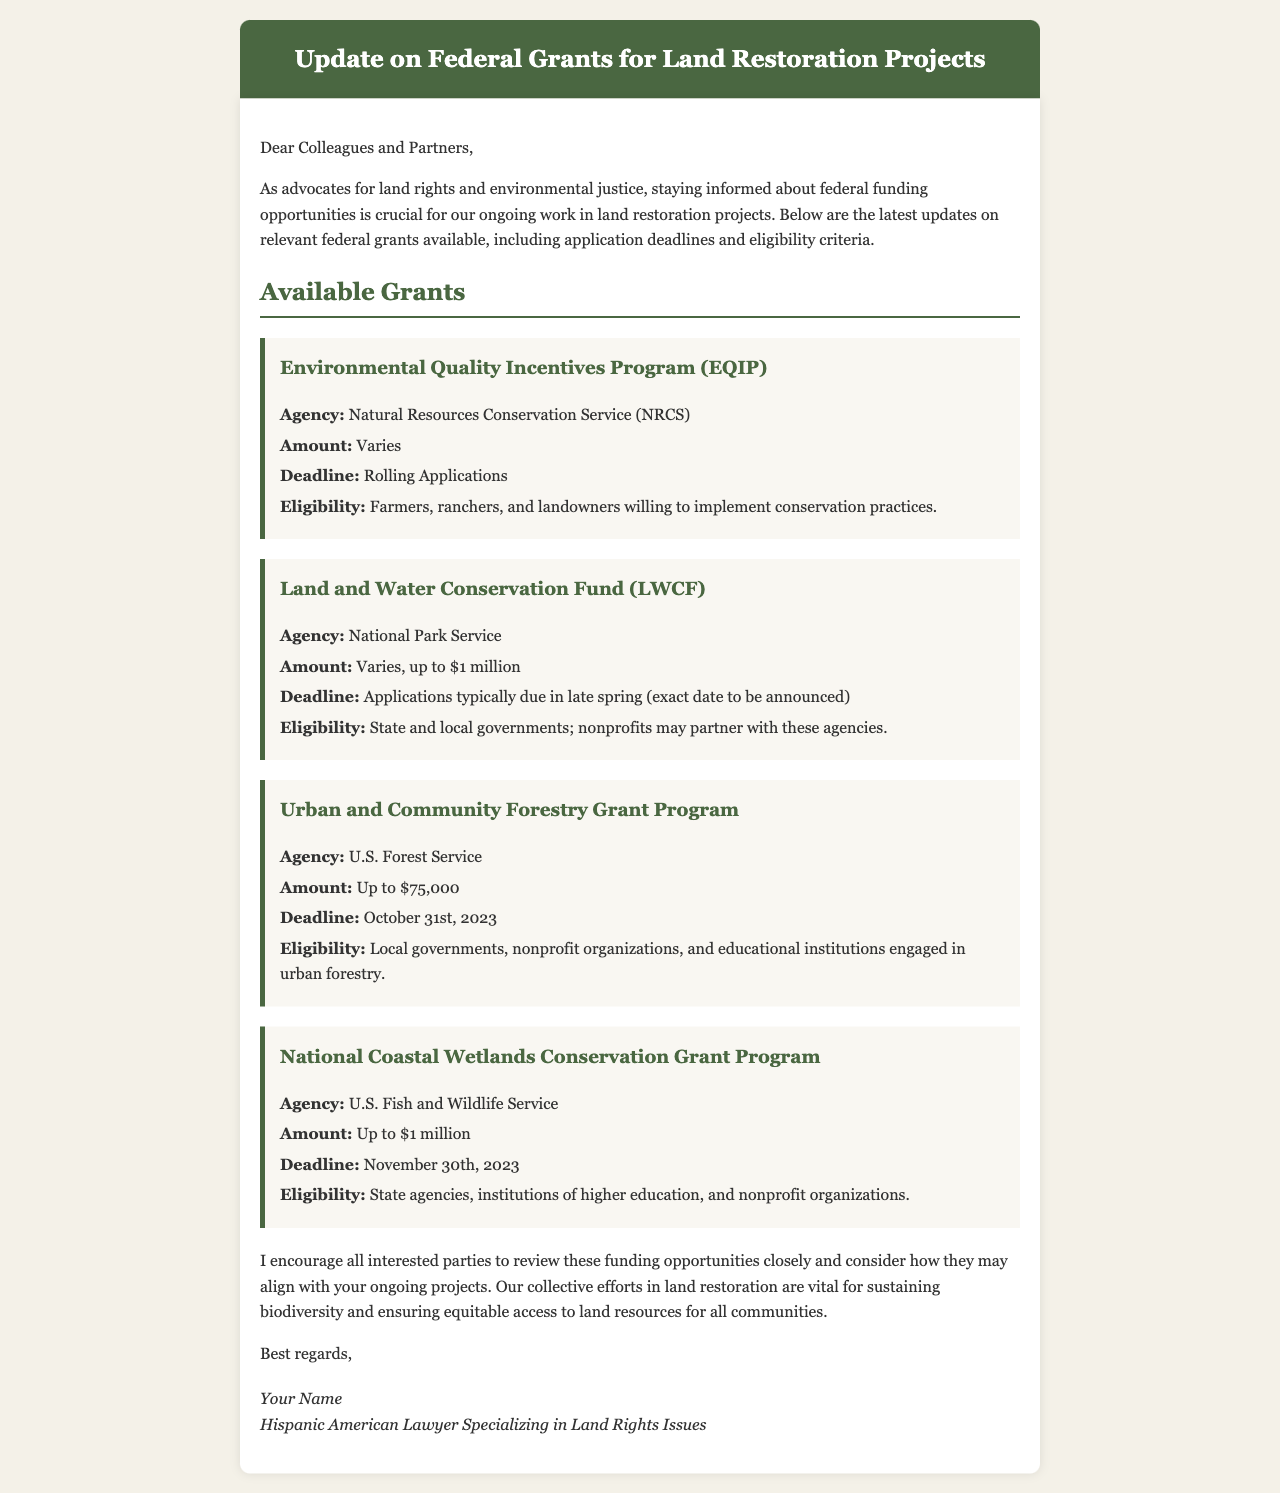What is the title of the document? The title is displayed prominently at the top of the document in the header section.
Answer: Update on Federal Grants for Land Restoration Projects What is the deadline for the Urban and Community Forestry Grant Program? The document specifies a specific date for this grant program under the deadline section.
Answer: October 31st, 2023 Which agency manages the Environmental Quality Incentives Program? The relevant agency is mentioned directly in the description of the grant.
Answer: Natural Resources Conservation Service (NRCS) What is the maximum amount available for the Land and Water Conservation Fund? The document indicates this information directly under the amount section for the specific grant.
Answer: up to $1 million Who is eligible to apply for the National Coastal Wetlands Conservation Grant Program? The eligibility criteria for this specific grant are listed under its description.
Answer: State agencies, institutions of higher education, and nonprofit organizations How many grants are mentioned in the document? The total number of grants is noted in the Available Grants section.
Answer: Four What type of organizations can partner with state and local governments for the Land and Water Conservation Fund? This information is provided in the eligibility criteria for the related grant.
Answer: Nonprofits What is the main purpose of the email? The purpose is summarized in the introductory paragraph of the document.
Answer: Inform about federal funding opportunities What should interested parties do with the funding opportunities? This action is advised clearly in the closing statements of the content.
Answer: Review them closely 